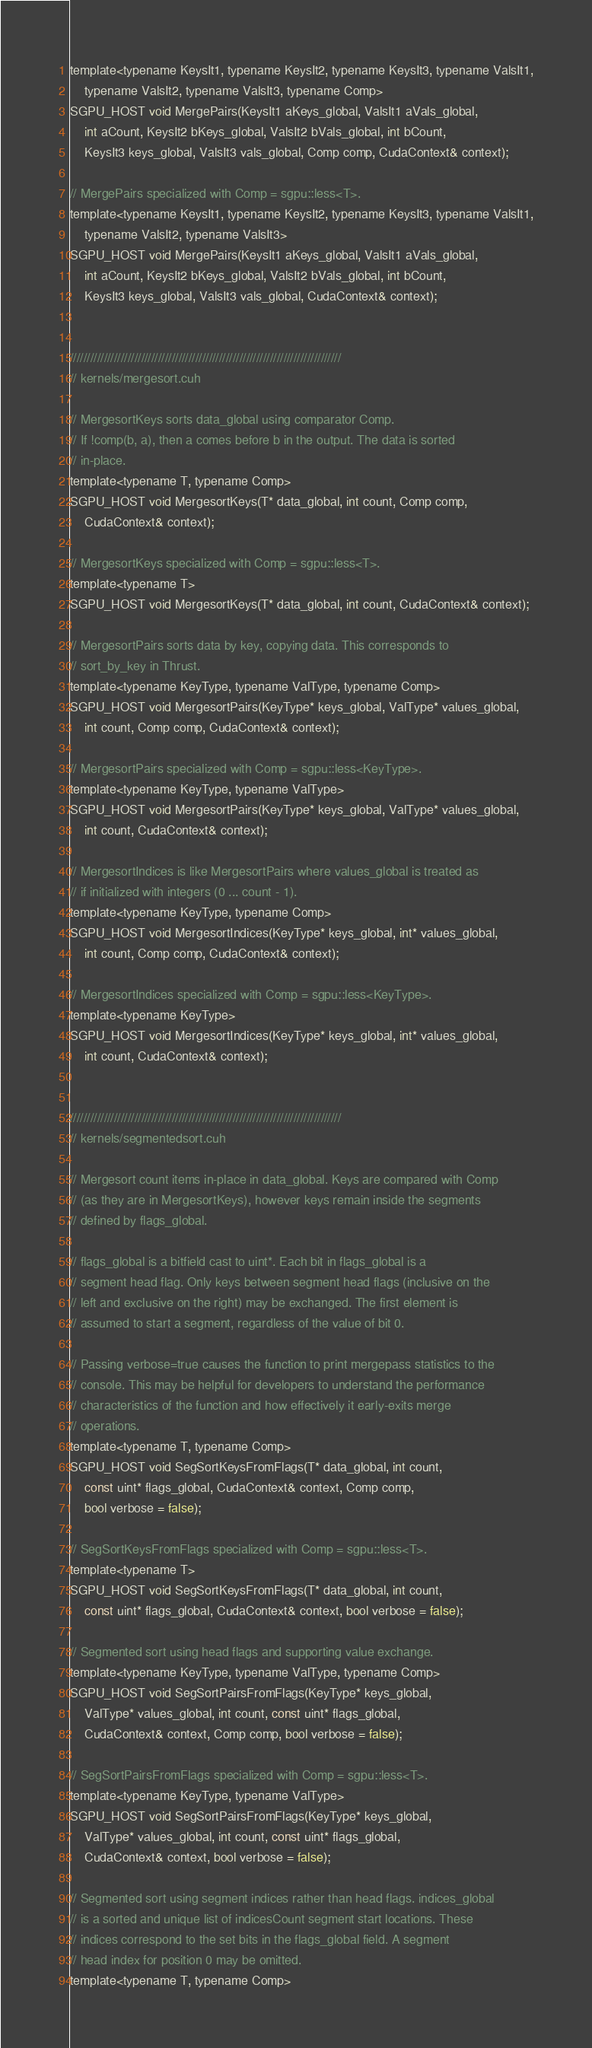Convert code to text. <code><loc_0><loc_0><loc_500><loc_500><_Cuda_>template<typename KeysIt1, typename KeysIt2, typename KeysIt3, typename ValsIt1,
	typename ValsIt2, typename ValsIt3, typename Comp>
SGPU_HOST void MergePairs(KeysIt1 aKeys_global, ValsIt1 aVals_global,
	int aCount, KeysIt2 bKeys_global, ValsIt2 bVals_global, int bCount,
	KeysIt3 keys_global, ValsIt3 vals_global, Comp comp, CudaContext& context);

// MergePairs specialized with Comp = sgpu::less<T>.
template<typename KeysIt1, typename KeysIt2, typename KeysIt3, typename ValsIt1,
	typename ValsIt2, typename ValsIt3>
SGPU_HOST void MergePairs(KeysIt1 aKeys_global, ValsIt1 aVals_global,
	int aCount, KeysIt2 bKeys_global, ValsIt2 bVals_global, int bCount,
	KeysIt3 keys_global, ValsIt3 vals_global, CudaContext& context);


////////////////////////////////////////////////////////////////////////////////
// kernels/mergesort.cuh

// MergesortKeys sorts data_global using comparator Comp.
// If !comp(b, a), then a comes before b in the output. The data is sorted
// in-place.
template<typename T, typename Comp>
SGPU_HOST void MergesortKeys(T* data_global, int count, Comp comp,
	CudaContext& context);

// MergesortKeys specialized with Comp = sgpu::less<T>.
template<typename T>
SGPU_HOST void MergesortKeys(T* data_global, int count, CudaContext& context);

// MergesortPairs sorts data by key, copying data. This corresponds to
// sort_by_key in Thrust.
template<typename KeyType, typename ValType, typename Comp>
SGPU_HOST void MergesortPairs(KeyType* keys_global, ValType* values_global,
	int count, Comp comp, CudaContext& context);

// MergesortPairs specialized with Comp = sgpu::less<KeyType>.
template<typename KeyType, typename ValType>
SGPU_HOST void MergesortPairs(KeyType* keys_global, ValType* values_global,
	int count, CudaContext& context);

// MergesortIndices is like MergesortPairs where values_global is treated as
// if initialized with integers (0 ... count - 1).
template<typename KeyType, typename Comp>
SGPU_HOST void MergesortIndices(KeyType* keys_global, int* values_global,
	int count, Comp comp, CudaContext& context);

// MergesortIndices specialized with Comp = sgpu::less<KeyType>.
template<typename KeyType>
SGPU_HOST void MergesortIndices(KeyType* keys_global, int* values_global,
	int count, CudaContext& context);


////////////////////////////////////////////////////////////////////////////////
// kernels/segmentedsort.cuh

// Mergesort count items in-place in data_global. Keys are compared with Comp
// (as they are in MergesortKeys), however keys remain inside the segments
// defined by flags_global.

// flags_global is a bitfield cast to uint*. Each bit in flags_global is a
// segment head flag. Only keys between segment head flags (inclusive on the
// left and exclusive on the right) may be exchanged. The first element is
// assumed to start a segment, regardless of the value of bit 0.

// Passing verbose=true causes the function to print mergepass statistics to the
// console. This may be helpful for developers to understand the performance
// characteristics of the function and how effectively it early-exits merge
// operations.
template<typename T, typename Comp>
SGPU_HOST void SegSortKeysFromFlags(T* data_global, int count,
	const uint* flags_global, CudaContext& context, Comp comp,
	bool verbose = false);

// SegSortKeysFromFlags specialized with Comp = sgpu::less<T>.
template<typename T>
SGPU_HOST void SegSortKeysFromFlags(T* data_global, int count,
	const uint* flags_global, CudaContext& context, bool verbose = false);

// Segmented sort using head flags and supporting value exchange.
template<typename KeyType, typename ValType, typename Comp>
SGPU_HOST void SegSortPairsFromFlags(KeyType* keys_global,
	ValType* values_global, int count, const uint* flags_global,
	CudaContext& context, Comp comp, bool verbose = false);

// SegSortPairsFromFlags specialized with Comp = sgpu::less<T>.
template<typename KeyType, typename ValType>
SGPU_HOST void SegSortPairsFromFlags(KeyType* keys_global,
	ValType* values_global, int count, const uint* flags_global,
	CudaContext& context, bool verbose = false);

// Segmented sort using segment indices rather than head flags. indices_global
// is a sorted and unique list of indicesCount segment start locations. These
// indices correspond to the set bits in the flags_global field. A segment
// head index for position 0 may be omitted.
template<typename T, typename Comp></code> 